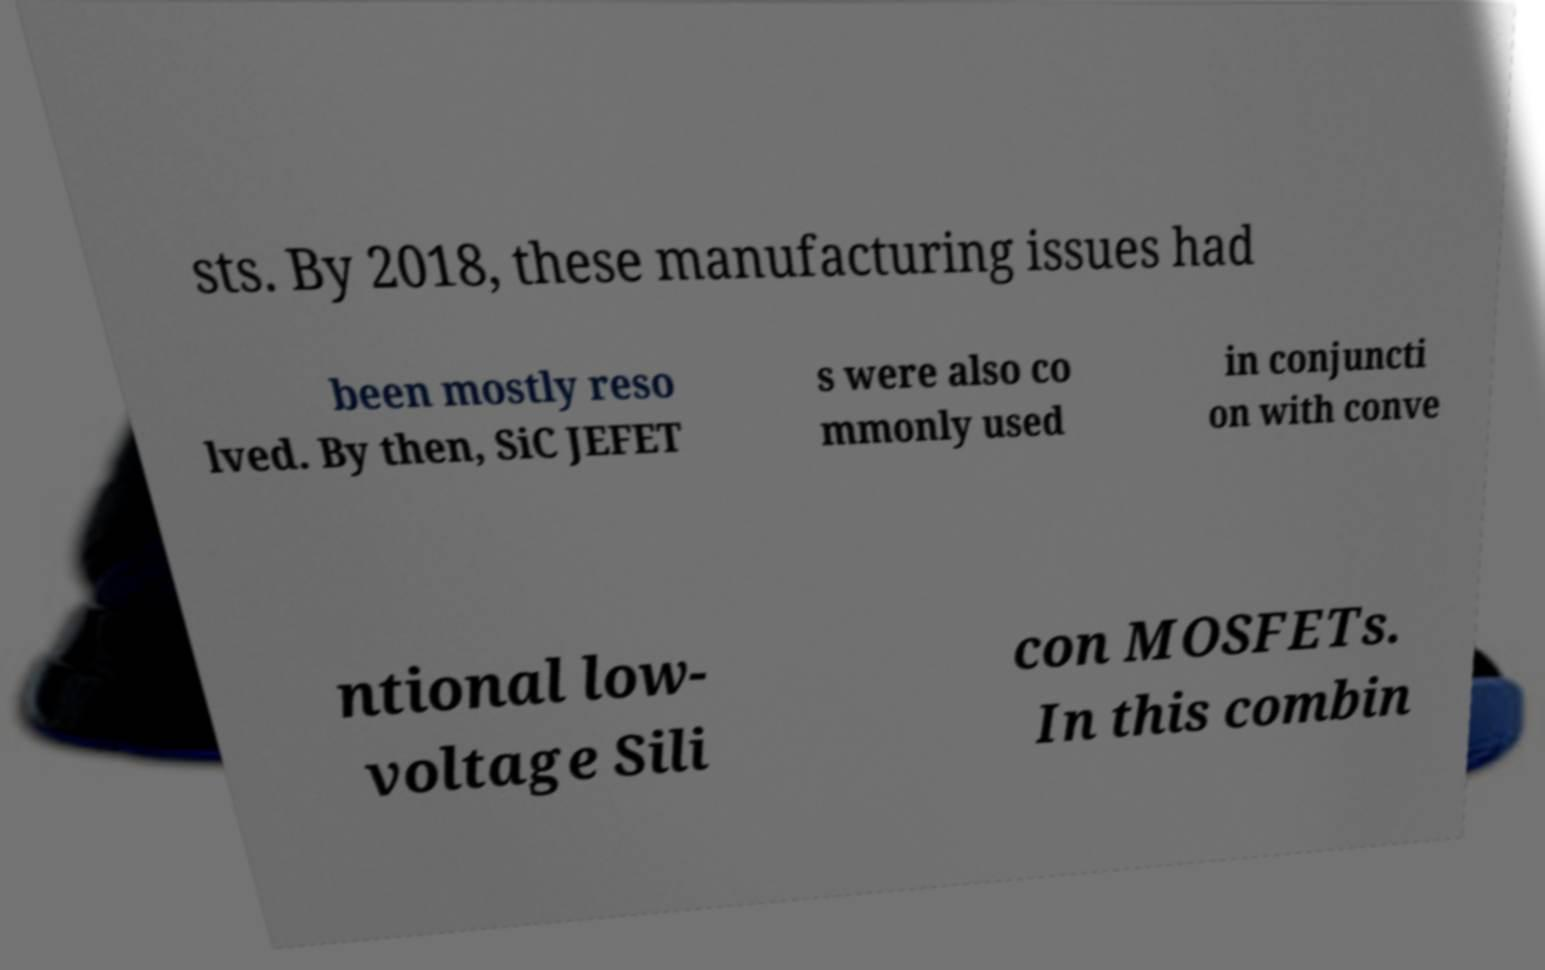Please read and relay the text visible in this image. What does it say? sts. By 2018, these manufacturing issues had been mostly reso lved. By then, SiC JEFET s were also co mmonly used in conjuncti on with conve ntional low- voltage Sili con MOSFETs. In this combin 